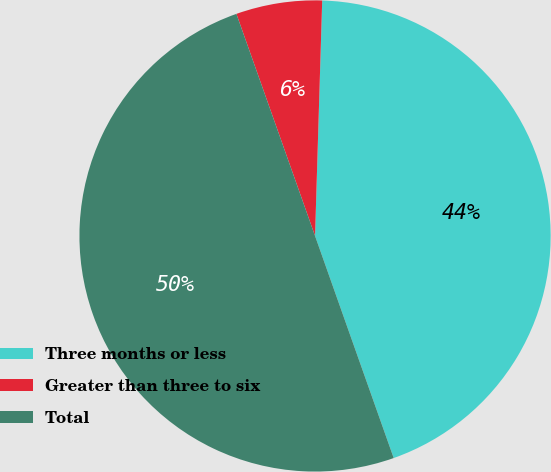Convert chart. <chart><loc_0><loc_0><loc_500><loc_500><pie_chart><fcel>Three months or less<fcel>Greater than three to six<fcel>Total<nl><fcel>44.1%<fcel>5.9%<fcel>50.0%<nl></chart> 